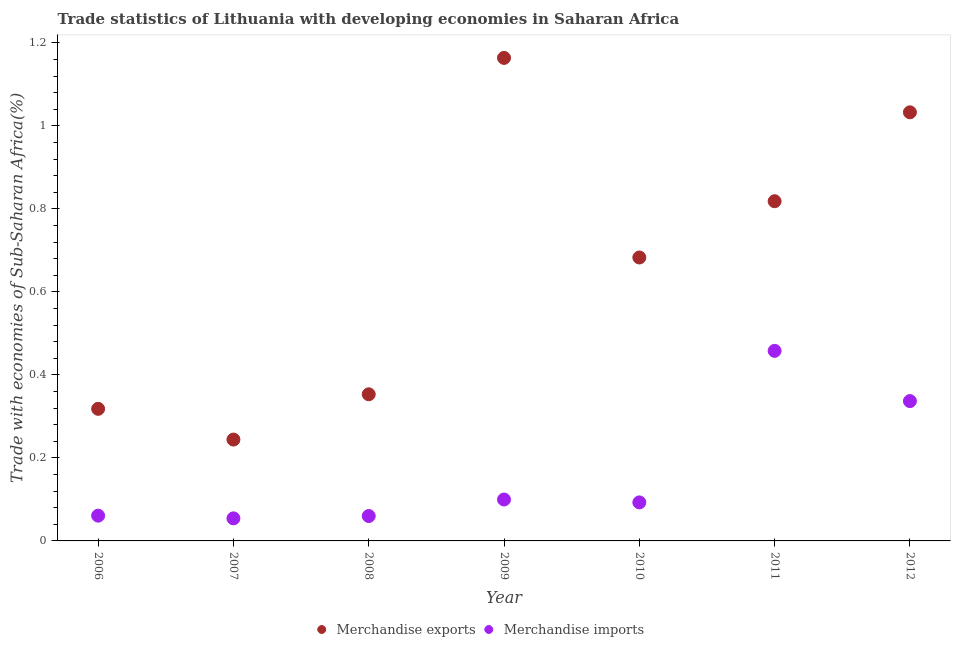How many different coloured dotlines are there?
Provide a short and direct response. 2. Is the number of dotlines equal to the number of legend labels?
Keep it short and to the point. Yes. What is the merchandise exports in 2008?
Keep it short and to the point. 0.35. Across all years, what is the maximum merchandise exports?
Give a very brief answer. 1.16. Across all years, what is the minimum merchandise imports?
Ensure brevity in your answer.  0.05. In which year was the merchandise exports maximum?
Offer a very short reply. 2009. In which year was the merchandise exports minimum?
Your answer should be very brief. 2007. What is the total merchandise imports in the graph?
Your answer should be very brief. 1.16. What is the difference between the merchandise exports in 2008 and that in 2011?
Make the answer very short. -0.47. What is the difference between the merchandise imports in 2010 and the merchandise exports in 2012?
Offer a terse response. -0.94. What is the average merchandise exports per year?
Your answer should be compact. 0.66. In the year 2010, what is the difference between the merchandise exports and merchandise imports?
Make the answer very short. 0.59. In how many years, is the merchandise exports greater than 0.8400000000000001 %?
Your answer should be very brief. 2. What is the ratio of the merchandise exports in 2008 to that in 2011?
Your answer should be very brief. 0.43. Is the difference between the merchandise imports in 2009 and 2012 greater than the difference between the merchandise exports in 2009 and 2012?
Your answer should be compact. No. What is the difference between the highest and the second highest merchandise imports?
Provide a short and direct response. 0.12. What is the difference between the highest and the lowest merchandise imports?
Keep it short and to the point. 0.4. In how many years, is the merchandise exports greater than the average merchandise exports taken over all years?
Your response must be concise. 4. Is the merchandise exports strictly greater than the merchandise imports over the years?
Your answer should be very brief. Yes. How many dotlines are there?
Your answer should be compact. 2. How many years are there in the graph?
Make the answer very short. 7. What is the difference between two consecutive major ticks on the Y-axis?
Provide a short and direct response. 0.2. Does the graph contain any zero values?
Give a very brief answer. No. What is the title of the graph?
Your answer should be very brief. Trade statistics of Lithuania with developing economies in Saharan Africa. Does "Primary completion rate" appear as one of the legend labels in the graph?
Give a very brief answer. No. What is the label or title of the X-axis?
Your answer should be very brief. Year. What is the label or title of the Y-axis?
Ensure brevity in your answer.  Trade with economies of Sub-Saharan Africa(%). What is the Trade with economies of Sub-Saharan Africa(%) in Merchandise exports in 2006?
Your answer should be very brief. 0.32. What is the Trade with economies of Sub-Saharan Africa(%) of Merchandise imports in 2006?
Provide a short and direct response. 0.06. What is the Trade with economies of Sub-Saharan Africa(%) in Merchandise exports in 2007?
Your response must be concise. 0.24. What is the Trade with economies of Sub-Saharan Africa(%) of Merchandise imports in 2007?
Your answer should be very brief. 0.05. What is the Trade with economies of Sub-Saharan Africa(%) in Merchandise exports in 2008?
Ensure brevity in your answer.  0.35. What is the Trade with economies of Sub-Saharan Africa(%) of Merchandise imports in 2008?
Your answer should be very brief. 0.06. What is the Trade with economies of Sub-Saharan Africa(%) of Merchandise exports in 2009?
Provide a short and direct response. 1.16. What is the Trade with economies of Sub-Saharan Africa(%) in Merchandise imports in 2009?
Your response must be concise. 0.1. What is the Trade with economies of Sub-Saharan Africa(%) of Merchandise exports in 2010?
Provide a short and direct response. 0.68. What is the Trade with economies of Sub-Saharan Africa(%) of Merchandise imports in 2010?
Provide a short and direct response. 0.09. What is the Trade with economies of Sub-Saharan Africa(%) in Merchandise exports in 2011?
Your response must be concise. 0.82. What is the Trade with economies of Sub-Saharan Africa(%) in Merchandise imports in 2011?
Provide a short and direct response. 0.46. What is the Trade with economies of Sub-Saharan Africa(%) in Merchandise exports in 2012?
Keep it short and to the point. 1.03. What is the Trade with economies of Sub-Saharan Africa(%) of Merchandise imports in 2012?
Your answer should be very brief. 0.34. Across all years, what is the maximum Trade with economies of Sub-Saharan Africa(%) of Merchandise exports?
Your answer should be very brief. 1.16. Across all years, what is the maximum Trade with economies of Sub-Saharan Africa(%) in Merchandise imports?
Provide a short and direct response. 0.46. Across all years, what is the minimum Trade with economies of Sub-Saharan Africa(%) in Merchandise exports?
Offer a very short reply. 0.24. Across all years, what is the minimum Trade with economies of Sub-Saharan Africa(%) in Merchandise imports?
Make the answer very short. 0.05. What is the total Trade with economies of Sub-Saharan Africa(%) of Merchandise exports in the graph?
Provide a succinct answer. 4.61. What is the total Trade with economies of Sub-Saharan Africa(%) in Merchandise imports in the graph?
Keep it short and to the point. 1.16. What is the difference between the Trade with economies of Sub-Saharan Africa(%) of Merchandise exports in 2006 and that in 2007?
Your response must be concise. 0.07. What is the difference between the Trade with economies of Sub-Saharan Africa(%) in Merchandise imports in 2006 and that in 2007?
Provide a short and direct response. 0.01. What is the difference between the Trade with economies of Sub-Saharan Africa(%) in Merchandise exports in 2006 and that in 2008?
Your response must be concise. -0.04. What is the difference between the Trade with economies of Sub-Saharan Africa(%) in Merchandise imports in 2006 and that in 2008?
Provide a succinct answer. 0. What is the difference between the Trade with economies of Sub-Saharan Africa(%) in Merchandise exports in 2006 and that in 2009?
Ensure brevity in your answer.  -0.85. What is the difference between the Trade with economies of Sub-Saharan Africa(%) of Merchandise imports in 2006 and that in 2009?
Offer a very short reply. -0.04. What is the difference between the Trade with economies of Sub-Saharan Africa(%) of Merchandise exports in 2006 and that in 2010?
Ensure brevity in your answer.  -0.36. What is the difference between the Trade with economies of Sub-Saharan Africa(%) of Merchandise imports in 2006 and that in 2010?
Your response must be concise. -0.03. What is the difference between the Trade with economies of Sub-Saharan Africa(%) of Merchandise exports in 2006 and that in 2011?
Offer a very short reply. -0.5. What is the difference between the Trade with economies of Sub-Saharan Africa(%) of Merchandise imports in 2006 and that in 2011?
Your response must be concise. -0.4. What is the difference between the Trade with economies of Sub-Saharan Africa(%) of Merchandise exports in 2006 and that in 2012?
Your answer should be compact. -0.71. What is the difference between the Trade with economies of Sub-Saharan Africa(%) in Merchandise imports in 2006 and that in 2012?
Offer a terse response. -0.28. What is the difference between the Trade with economies of Sub-Saharan Africa(%) of Merchandise exports in 2007 and that in 2008?
Give a very brief answer. -0.11. What is the difference between the Trade with economies of Sub-Saharan Africa(%) of Merchandise imports in 2007 and that in 2008?
Keep it short and to the point. -0.01. What is the difference between the Trade with economies of Sub-Saharan Africa(%) in Merchandise exports in 2007 and that in 2009?
Your answer should be very brief. -0.92. What is the difference between the Trade with economies of Sub-Saharan Africa(%) in Merchandise imports in 2007 and that in 2009?
Give a very brief answer. -0.05. What is the difference between the Trade with economies of Sub-Saharan Africa(%) of Merchandise exports in 2007 and that in 2010?
Your answer should be very brief. -0.44. What is the difference between the Trade with economies of Sub-Saharan Africa(%) of Merchandise imports in 2007 and that in 2010?
Offer a very short reply. -0.04. What is the difference between the Trade with economies of Sub-Saharan Africa(%) in Merchandise exports in 2007 and that in 2011?
Your answer should be compact. -0.57. What is the difference between the Trade with economies of Sub-Saharan Africa(%) in Merchandise imports in 2007 and that in 2011?
Provide a short and direct response. -0.4. What is the difference between the Trade with economies of Sub-Saharan Africa(%) in Merchandise exports in 2007 and that in 2012?
Your response must be concise. -0.79. What is the difference between the Trade with economies of Sub-Saharan Africa(%) in Merchandise imports in 2007 and that in 2012?
Offer a very short reply. -0.28. What is the difference between the Trade with economies of Sub-Saharan Africa(%) of Merchandise exports in 2008 and that in 2009?
Give a very brief answer. -0.81. What is the difference between the Trade with economies of Sub-Saharan Africa(%) of Merchandise imports in 2008 and that in 2009?
Your answer should be compact. -0.04. What is the difference between the Trade with economies of Sub-Saharan Africa(%) of Merchandise exports in 2008 and that in 2010?
Offer a terse response. -0.33. What is the difference between the Trade with economies of Sub-Saharan Africa(%) of Merchandise imports in 2008 and that in 2010?
Provide a short and direct response. -0.03. What is the difference between the Trade with economies of Sub-Saharan Africa(%) in Merchandise exports in 2008 and that in 2011?
Your answer should be compact. -0.47. What is the difference between the Trade with economies of Sub-Saharan Africa(%) of Merchandise imports in 2008 and that in 2011?
Your response must be concise. -0.4. What is the difference between the Trade with economies of Sub-Saharan Africa(%) of Merchandise exports in 2008 and that in 2012?
Your response must be concise. -0.68. What is the difference between the Trade with economies of Sub-Saharan Africa(%) in Merchandise imports in 2008 and that in 2012?
Offer a very short reply. -0.28. What is the difference between the Trade with economies of Sub-Saharan Africa(%) of Merchandise exports in 2009 and that in 2010?
Provide a short and direct response. 0.48. What is the difference between the Trade with economies of Sub-Saharan Africa(%) in Merchandise imports in 2009 and that in 2010?
Provide a succinct answer. 0.01. What is the difference between the Trade with economies of Sub-Saharan Africa(%) of Merchandise exports in 2009 and that in 2011?
Keep it short and to the point. 0.35. What is the difference between the Trade with economies of Sub-Saharan Africa(%) in Merchandise imports in 2009 and that in 2011?
Your answer should be compact. -0.36. What is the difference between the Trade with economies of Sub-Saharan Africa(%) in Merchandise exports in 2009 and that in 2012?
Your answer should be compact. 0.13. What is the difference between the Trade with economies of Sub-Saharan Africa(%) in Merchandise imports in 2009 and that in 2012?
Make the answer very short. -0.24. What is the difference between the Trade with economies of Sub-Saharan Africa(%) of Merchandise exports in 2010 and that in 2011?
Your response must be concise. -0.14. What is the difference between the Trade with economies of Sub-Saharan Africa(%) in Merchandise imports in 2010 and that in 2011?
Provide a succinct answer. -0.37. What is the difference between the Trade with economies of Sub-Saharan Africa(%) in Merchandise exports in 2010 and that in 2012?
Provide a short and direct response. -0.35. What is the difference between the Trade with economies of Sub-Saharan Africa(%) of Merchandise imports in 2010 and that in 2012?
Keep it short and to the point. -0.24. What is the difference between the Trade with economies of Sub-Saharan Africa(%) in Merchandise exports in 2011 and that in 2012?
Give a very brief answer. -0.21. What is the difference between the Trade with economies of Sub-Saharan Africa(%) in Merchandise imports in 2011 and that in 2012?
Your answer should be compact. 0.12. What is the difference between the Trade with economies of Sub-Saharan Africa(%) of Merchandise exports in 2006 and the Trade with economies of Sub-Saharan Africa(%) of Merchandise imports in 2007?
Give a very brief answer. 0.26. What is the difference between the Trade with economies of Sub-Saharan Africa(%) in Merchandise exports in 2006 and the Trade with economies of Sub-Saharan Africa(%) in Merchandise imports in 2008?
Give a very brief answer. 0.26. What is the difference between the Trade with economies of Sub-Saharan Africa(%) in Merchandise exports in 2006 and the Trade with economies of Sub-Saharan Africa(%) in Merchandise imports in 2009?
Give a very brief answer. 0.22. What is the difference between the Trade with economies of Sub-Saharan Africa(%) of Merchandise exports in 2006 and the Trade with economies of Sub-Saharan Africa(%) of Merchandise imports in 2010?
Provide a succinct answer. 0.23. What is the difference between the Trade with economies of Sub-Saharan Africa(%) in Merchandise exports in 2006 and the Trade with economies of Sub-Saharan Africa(%) in Merchandise imports in 2011?
Your answer should be compact. -0.14. What is the difference between the Trade with economies of Sub-Saharan Africa(%) of Merchandise exports in 2006 and the Trade with economies of Sub-Saharan Africa(%) of Merchandise imports in 2012?
Provide a short and direct response. -0.02. What is the difference between the Trade with economies of Sub-Saharan Africa(%) in Merchandise exports in 2007 and the Trade with economies of Sub-Saharan Africa(%) in Merchandise imports in 2008?
Your answer should be very brief. 0.18. What is the difference between the Trade with economies of Sub-Saharan Africa(%) in Merchandise exports in 2007 and the Trade with economies of Sub-Saharan Africa(%) in Merchandise imports in 2009?
Provide a succinct answer. 0.14. What is the difference between the Trade with economies of Sub-Saharan Africa(%) of Merchandise exports in 2007 and the Trade with economies of Sub-Saharan Africa(%) of Merchandise imports in 2010?
Provide a succinct answer. 0.15. What is the difference between the Trade with economies of Sub-Saharan Africa(%) of Merchandise exports in 2007 and the Trade with economies of Sub-Saharan Africa(%) of Merchandise imports in 2011?
Keep it short and to the point. -0.21. What is the difference between the Trade with economies of Sub-Saharan Africa(%) of Merchandise exports in 2007 and the Trade with economies of Sub-Saharan Africa(%) of Merchandise imports in 2012?
Ensure brevity in your answer.  -0.09. What is the difference between the Trade with economies of Sub-Saharan Africa(%) in Merchandise exports in 2008 and the Trade with economies of Sub-Saharan Africa(%) in Merchandise imports in 2009?
Your answer should be very brief. 0.25. What is the difference between the Trade with economies of Sub-Saharan Africa(%) of Merchandise exports in 2008 and the Trade with economies of Sub-Saharan Africa(%) of Merchandise imports in 2010?
Ensure brevity in your answer.  0.26. What is the difference between the Trade with economies of Sub-Saharan Africa(%) in Merchandise exports in 2008 and the Trade with economies of Sub-Saharan Africa(%) in Merchandise imports in 2011?
Keep it short and to the point. -0.1. What is the difference between the Trade with economies of Sub-Saharan Africa(%) in Merchandise exports in 2008 and the Trade with economies of Sub-Saharan Africa(%) in Merchandise imports in 2012?
Give a very brief answer. 0.02. What is the difference between the Trade with economies of Sub-Saharan Africa(%) in Merchandise exports in 2009 and the Trade with economies of Sub-Saharan Africa(%) in Merchandise imports in 2010?
Provide a short and direct response. 1.07. What is the difference between the Trade with economies of Sub-Saharan Africa(%) of Merchandise exports in 2009 and the Trade with economies of Sub-Saharan Africa(%) of Merchandise imports in 2011?
Offer a very short reply. 0.71. What is the difference between the Trade with economies of Sub-Saharan Africa(%) in Merchandise exports in 2009 and the Trade with economies of Sub-Saharan Africa(%) in Merchandise imports in 2012?
Your answer should be compact. 0.83. What is the difference between the Trade with economies of Sub-Saharan Africa(%) of Merchandise exports in 2010 and the Trade with economies of Sub-Saharan Africa(%) of Merchandise imports in 2011?
Provide a short and direct response. 0.22. What is the difference between the Trade with economies of Sub-Saharan Africa(%) in Merchandise exports in 2010 and the Trade with economies of Sub-Saharan Africa(%) in Merchandise imports in 2012?
Make the answer very short. 0.35. What is the difference between the Trade with economies of Sub-Saharan Africa(%) of Merchandise exports in 2011 and the Trade with economies of Sub-Saharan Africa(%) of Merchandise imports in 2012?
Your answer should be compact. 0.48. What is the average Trade with economies of Sub-Saharan Africa(%) in Merchandise exports per year?
Offer a very short reply. 0.66. What is the average Trade with economies of Sub-Saharan Africa(%) of Merchandise imports per year?
Give a very brief answer. 0.17. In the year 2006, what is the difference between the Trade with economies of Sub-Saharan Africa(%) in Merchandise exports and Trade with economies of Sub-Saharan Africa(%) in Merchandise imports?
Your answer should be compact. 0.26. In the year 2007, what is the difference between the Trade with economies of Sub-Saharan Africa(%) of Merchandise exports and Trade with economies of Sub-Saharan Africa(%) of Merchandise imports?
Your response must be concise. 0.19. In the year 2008, what is the difference between the Trade with economies of Sub-Saharan Africa(%) of Merchandise exports and Trade with economies of Sub-Saharan Africa(%) of Merchandise imports?
Your answer should be very brief. 0.29. In the year 2009, what is the difference between the Trade with economies of Sub-Saharan Africa(%) of Merchandise exports and Trade with economies of Sub-Saharan Africa(%) of Merchandise imports?
Offer a very short reply. 1.06. In the year 2010, what is the difference between the Trade with economies of Sub-Saharan Africa(%) of Merchandise exports and Trade with economies of Sub-Saharan Africa(%) of Merchandise imports?
Provide a short and direct response. 0.59. In the year 2011, what is the difference between the Trade with economies of Sub-Saharan Africa(%) of Merchandise exports and Trade with economies of Sub-Saharan Africa(%) of Merchandise imports?
Your answer should be compact. 0.36. In the year 2012, what is the difference between the Trade with economies of Sub-Saharan Africa(%) of Merchandise exports and Trade with economies of Sub-Saharan Africa(%) of Merchandise imports?
Provide a succinct answer. 0.7. What is the ratio of the Trade with economies of Sub-Saharan Africa(%) in Merchandise exports in 2006 to that in 2007?
Your answer should be compact. 1.3. What is the ratio of the Trade with economies of Sub-Saharan Africa(%) in Merchandise imports in 2006 to that in 2007?
Your response must be concise. 1.12. What is the ratio of the Trade with economies of Sub-Saharan Africa(%) of Merchandise exports in 2006 to that in 2008?
Your response must be concise. 0.9. What is the ratio of the Trade with economies of Sub-Saharan Africa(%) of Merchandise imports in 2006 to that in 2008?
Ensure brevity in your answer.  1.01. What is the ratio of the Trade with economies of Sub-Saharan Africa(%) of Merchandise exports in 2006 to that in 2009?
Make the answer very short. 0.27. What is the ratio of the Trade with economies of Sub-Saharan Africa(%) in Merchandise imports in 2006 to that in 2009?
Your answer should be compact. 0.61. What is the ratio of the Trade with economies of Sub-Saharan Africa(%) of Merchandise exports in 2006 to that in 2010?
Provide a succinct answer. 0.47. What is the ratio of the Trade with economies of Sub-Saharan Africa(%) in Merchandise imports in 2006 to that in 2010?
Ensure brevity in your answer.  0.66. What is the ratio of the Trade with economies of Sub-Saharan Africa(%) in Merchandise exports in 2006 to that in 2011?
Your response must be concise. 0.39. What is the ratio of the Trade with economies of Sub-Saharan Africa(%) in Merchandise imports in 2006 to that in 2011?
Ensure brevity in your answer.  0.13. What is the ratio of the Trade with economies of Sub-Saharan Africa(%) in Merchandise exports in 2006 to that in 2012?
Make the answer very short. 0.31. What is the ratio of the Trade with economies of Sub-Saharan Africa(%) in Merchandise imports in 2006 to that in 2012?
Offer a terse response. 0.18. What is the ratio of the Trade with economies of Sub-Saharan Africa(%) in Merchandise exports in 2007 to that in 2008?
Provide a short and direct response. 0.69. What is the ratio of the Trade with economies of Sub-Saharan Africa(%) of Merchandise imports in 2007 to that in 2008?
Your answer should be very brief. 0.91. What is the ratio of the Trade with economies of Sub-Saharan Africa(%) in Merchandise exports in 2007 to that in 2009?
Keep it short and to the point. 0.21. What is the ratio of the Trade with economies of Sub-Saharan Africa(%) in Merchandise imports in 2007 to that in 2009?
Keep it short and to the point. 0.55. What is the ratio of the Trade with economies of Sub-Saharan Africa(%) of Merchandise exports in 2007 to that in 2010?
Provide a succinct answer. 0.36. What is the ratio of the Trade with economies of Sub-Saharan Africa(%) in Merchandise imports in 2007 to that in 2010?
Your answer should be compact. 0.59. What is the ratio of the Trade with economies of Sub-Saharan Africa(%) of Merchandise exports in 2007 to that in 2011?
Offer a terse response. 0.3. What is the ratio of the Trade with economies of Sub-Saharan Africa(%) of Merchandise imports in 2007 to that in 2011?
Offer a terse response. 0.12. What is the ratio of the Trade with economies of Sub-Saharan Africa(%) in Merchandise exports in 2007 to that in 2012?
Give a very brief answer. 0.24. What is the ratio of the Trade with economies of Sub-Saharan Africa(%) of Merchandise imports in 2007 to that in 2012?
Provide a short and direct response. 0.16. What is the ratio of the Trade with economies of Sub-Saharan Africa(%) of Merchandise exports in 2008 to that in 2009?
Your answer should be compact. 0.3. What is the ratio of the Trade with economies of Sub-Saharan Africa(%) of Merchandise imports in 2008 to that in 2009?
Your answer should be compact. 0.6. What is the ratio of the Trade with economies of Sub-Saharan Africa(%) in Merchandise exports in 2008 to that in 2010?
Provide a short and direct response. 0.52. What is the ratio of the Trade with economies of Sub-Saharan Africa(%) of Merchandise imports in 2008 to that in 2010?
Offer a terse response. 0.65. What is the ratio of the Trade with economies of Sub-Saharan Africa(%) in Merchandise exports in 2008 to that in 2011?
Your answer should be compact. 0.43. What is the ratio of the Trade with economies of Sub-Saharan Africa(%) in Merchandise imports in 2008 to that in 2011?
Make the answer very short. 0.13. What is the ratio of the Trade with economies of Sub-Saharan Africa(%) of Merchandise exports in 2008 to that in 2012?
Make the answer very short. 0.34. What is the ratio of the Trade with economies of Sub-Saharan Africa(%) of Merchandise imports in 2008 to that in 2012?
Your answer should be very brief. 0.18. What is the ratio of the Trade with economies of Sub-Saharan Africa(%) of Merchandise exports in 2009 to that in 2010?
Your response must be concise. 1.7. What is the ratio of the Trade with economies of Sub-Saharan Africa(%) of Merchandise imports in 2009 to that in 2010?
Your answer should be compact. 1.07. What is the ratio of the Trade with economies of Sub-Saharan Africa(%) of Merchandise exports in 2009 to that in 2011?
Make the answer very short. 1.42. What is the ratio of the Trade with economies of Sub-Saharan Africa(%) of Merchandise imports in 2009 to that in 2011?
Keep it short and to the point. 0.22. What is the ratio of the Trade with economies of Sub-Saharan Africa(%) in Merchandise exports in 2009 to that in 2012?
Your answer should be very brief. 1.13. What is the ratio of the Trade with economies of Sub-Saharan Africa(%) of Merchandise imports in 2009 to that in 2012?
Keep it short and to the point. 0.3. What is the ratio of the Trade with economies of Sub-Saharan Africa(%) in Merchandise exports in 2010 to that in 2011?
Make the answer very short. 0.83. What is the ratio of the Trade with economies of Sub-Saharan Africa(%) of Merchandise imports in 2010 to that in 2011?
Give a very brief answer. 0.2. What is the ratio of the Trade with economies of Sub-Saharan Africa(%) in Merchandise exports in 2010 to that in 2012?
Your answer should be compact. 0.66. What is the ratio of the Trade with economies of Sub-Saharan Africa(%) of Merchandise imports in 2010 to that in 2012?
Offer a very short reply. 0.28. What is the ratio of the Trade with economies of Sub-Saharan Africa(%) in Merchandise exports in 2011 to that in 2012?
Your answer should be compact. 0.79. What is the ratio of the Trade with economies of Sub-Saharan Africa(%) of Merchandise imports in 2011 to that in 2012?
Offer a very short reply. 1.36. What is the difference between the highest and the second highest Trade with economies of Sub-Saharan Africa(%) of Merchandise exports?
Make the answer very short. 0.13. What is the difference between the highest and the second highest Trade with economies of Sub-Saharan Africa(%) in Merchandise imports?
Your answer should be compact. 0.12. What is the difference between the highest and the lowest Trade with economies of Sub-Saharan Africa(%) of Merchandise exports?
Offer a very short reply. 0.92. What is the difference between the highest and the lowest Trade with economies of Sub-Saharan Africa(%) in Merchandise imports?
Your response must be concise. 0.4. 